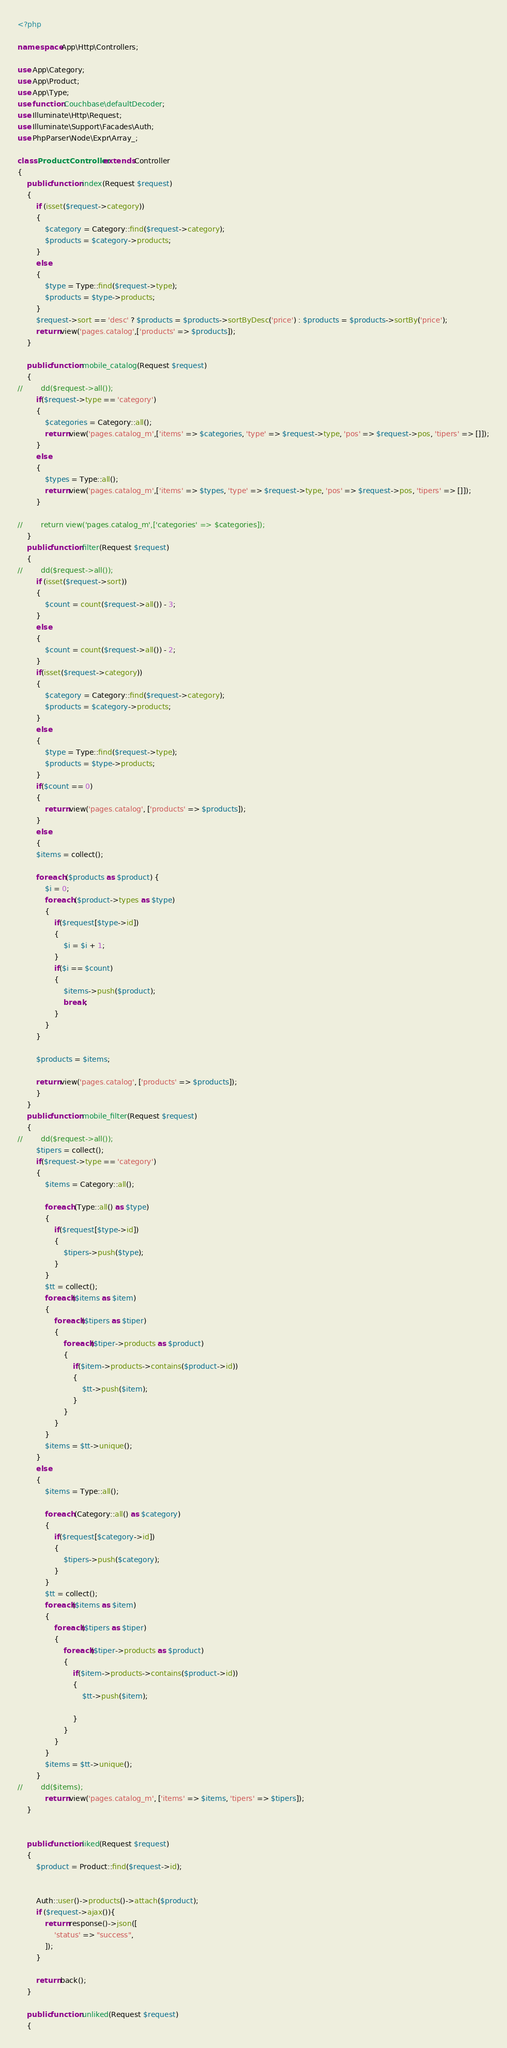Convert code to text. <code><loc_0><loc_0><loc_500><loc_500><_PHP_><?php

namespace App\Http\Controllers;

use App\Category;
use App\Product;
use App\Type;
use function Couchbase\defaultDecoder;
use Illuminate\Http\Request;
use Illuminate\Support\Facades\Auth;
use PhpParser\Node\Expr\Array_;

class ProductController extends Controller
{
    public function index(Request $request)
    {
        if (isset($request->category))
        {
            $category = Category::find($request->category);
            $products = $category->products;
        }
        else
        {
            $type = Type::find($request->type);
            $products = $type->products;
        }
        $request->sort == 'desc' ? $products = $products->sortByDesc('price') : $products = $products->sortBy('price');
        return view('pages.catalog',['products' => $products]);
    }

    public function mobile_catalog(Request $request)
    {
//        dd($request->all());
        if($request->type == 'category')
        {
            $categories = Category::all();
            return view('pages.catalog_m',['items' => $categories, 'type' => $request->type, 'pos' => $request->pos, 'tipers' => []]);
        }
        else
        {
            $types = Type::all();
            return view('pages.catalog_m',['items' => $types, 'type' => $request->type, 'pos' => $request->pos, 'tipers' => []]);
        }

//        return view('pages.catalog_m',['categories' => $categories]);
    }
    public function filter(Request $request)
    {
//        dd($request->all());
        if (isset($request->sort))
        {
            $count = count($request->all()) - 3;
        }
        else
        {
            $count = count($request->all()) - 2;
        }
        if(isset($request->category))
        {
            $category = Category::find($request->category);
            $products = $category->products;
        }
        else
        {
            $type = Type::find($request->type);
            $products = $type->products;
        }
        if($count == 0)
        {
            return view('pages.catalog', ['products' => $products]);
        }
        else
        {
        $items = collect();

        foreach ($products as $product) {
            $i = 0;
            foreach ($product->types as $type)
            {
                if($request[$type->id])
                {
                    $i = $i + 1;
                }
                if($i == $count)
                {
                    $items->push($product);
                    break;
                }
            }
        }

        $products = $items;

        return view('pages.catalog', ['products' => $products]);
        }
    }
    public function mobile_filter(Request $request)
    {
//        dd($request->all());
        $tipers = collect();
        if($request->type == 'category')
        {
            $items = Category::all();

            foreach (Type::all() as $type)
            {
                if($request[$type->id])
                {
                    $tipers->push($type);
                }
            }
            $tt = collect();
            foreach($items as $item)
            {
                foreach($tipers as $tiper)
                {
                    foreach($tiper->products as $product)
                    {
                        if($item->products->contains($product->id))
                        {
                            $tt->push($item);
                        }
                    }
                }
            }
            $items = $tt->unique();
        }
        else
        {
            $items = Type::all();

            foreach (Category::all() as $category)
            {
                if($request[$category->id])
                {
                    $tipers->push($category);
                }
            }
            $tt = collect();
            foreach($items as $item)
            {
                foreach($tipers as $tiper)
                {
                    foreach($tiper->products as $product)
                    {
                        if($item->products->contains($product->id))
                        {
                            $tt->push($item);

                        }
                    }
                }
            }
            $items = $tt->unique();
        }
//        dd($items);
            return view('pages.catalog_m', ['items' => $items, 'tipers' => $tipers]);
    }


    public function liked(Request $request)
    {
        $product = Product::find($request->id);


        Auth::user()->products()->attach($product);
        if ($request->ajax()){
            return response()->json([
                'status' => "success",
            ]);
        }

        return back();
    }

    public function unliked(Request $request)
    {</code> 